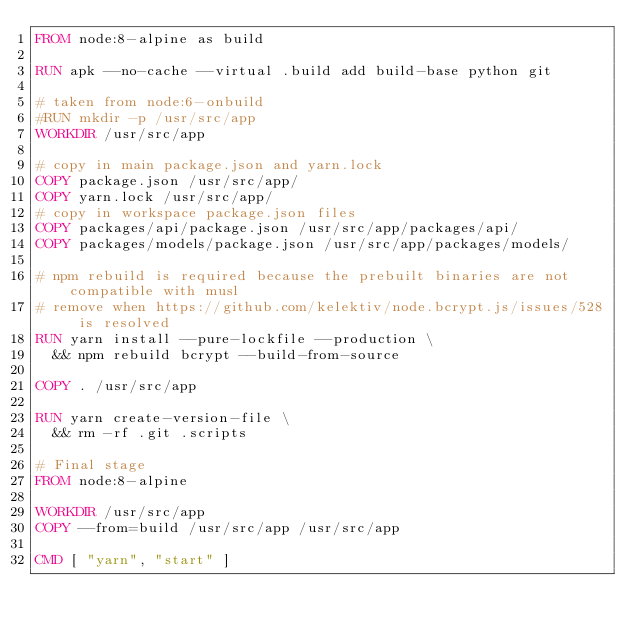Convert code to text. <code><loc_0><loc_0><loc_500><loc_500><_Dockerfile_>FROM node:8-alpine as build

RUN apk --no-cache --virtual .build add build-base python git

# taken from node:6-onbuild
#RUN mkdir -p /usr/src/app
WORKDIR /usr/src/app

# copy in main package.json and yarn.lock
COPY package.json /usr/src/app/
COPY yarn.lock /usr/src/app/
# copy in workspace package.json files
COPY packages/api/package.json /usr/src/app/packages/api/
COPY packages/models/package.json /usr/src/app/packages/models/

# npm rebuild is required because the prebuilt binaries are not compatible with musl
# remove when https://github.com/kelektiv/node.bcrypt.js/issues/528 is resolved
RUN yarn install --pure-lockfile --production \
  && npm rebuild bcrypt --build-from-source

COPY . /usr/src/app

RUN yarn create-version-file \
  && rm -rf .git .scripts

# Final stage
FROM node:8-alpine

WORKDIR /usr/src/app
COPY --from=build /usr/src/app /usr/src/app

CMD [ "yarn", "start" ]
</code> 